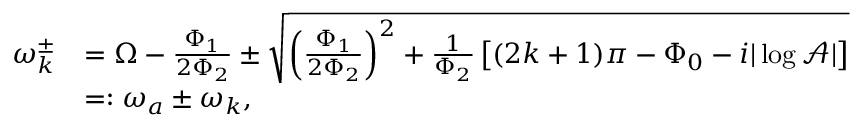<formula> <loc_0><loc_0><loc_500><loc_500>\begin{array} { r l } { \omega _ { k } ^ { \pm } } & { = \Omega - \frac { \Phi _ { 1 } } { 2 \Phi _ { 2 } } \pm \sqrt { \left ( \frac { \Phi _ { 1 } } { 2 \Phi _ { 2 } } \right ) ^ { 2 } + \frac { 1 } { \Phi _ { 2 } } \left [ ( 2 k + 1 ) \pi - \Phi _ { 0 } - i | \log \mathcal { A } | \right ] } } \\ & { = \colon \omega _ { a } \pm \omega _ { k } , } \end{array}</formula> 